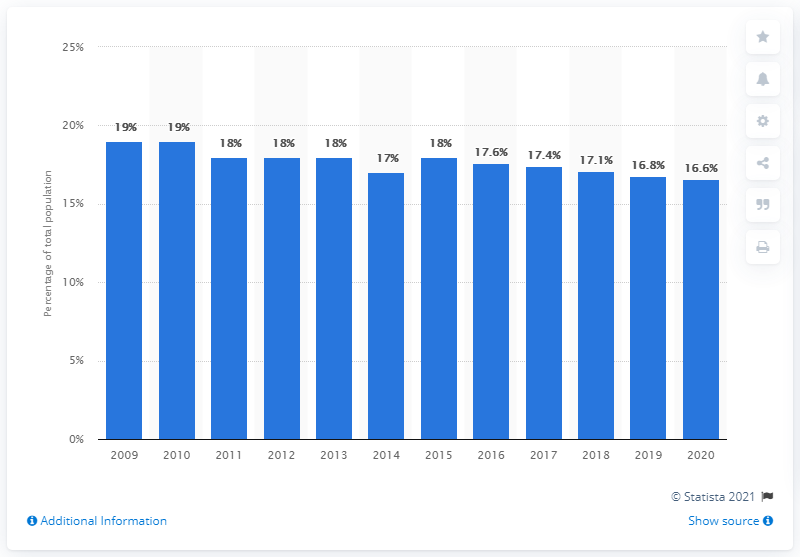Point out several critical features in this image. In 2020, children comprised 16.6 percent of Thailand's population. In 2009, the highest percentage of children in Thailand was 19%. 